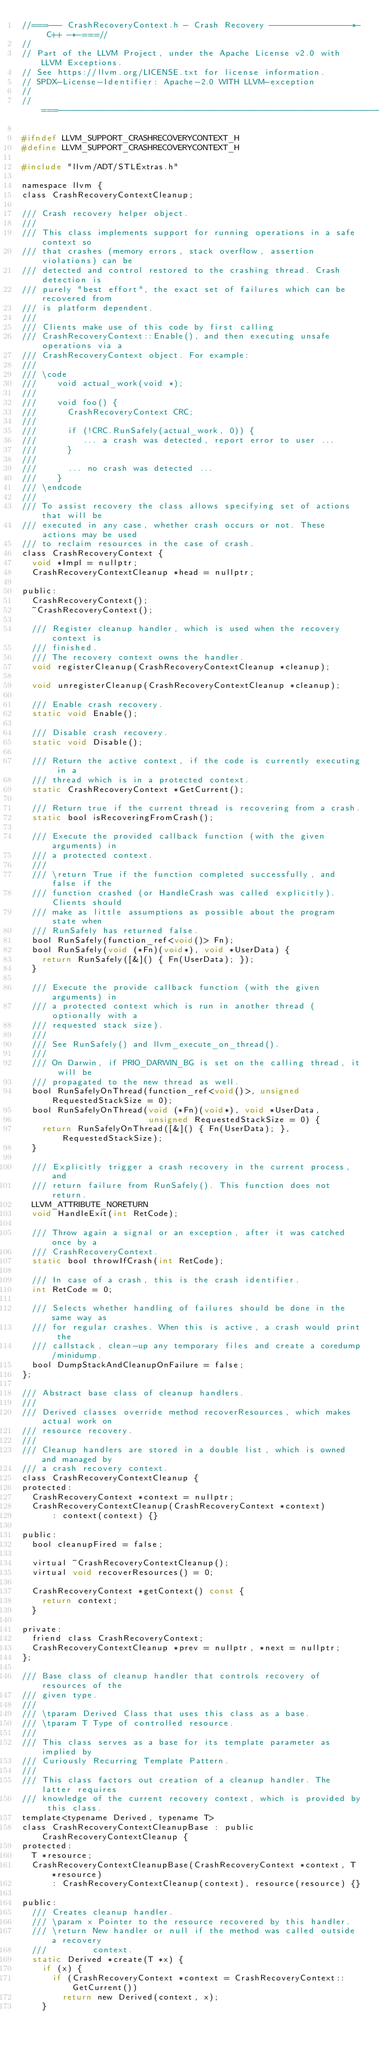<code> <loc_0><loc_0><loc_500><loc_500><_C_>//===--- CrashRecoveryContext.h - Crash Recovery ----------------*- C++ -*-===//
//
// Part of the LLVM Project, under the Apache License v2.0 with LLVM Exceptions.
// See https://llvm.org/LICENSE.txt for license information.
// SPDX-License-Identifier: Apache-2.0 WITH LLVM-exception
//
//===----------------------------------------------------------------------===//

#ifndef LLVM_SUPPORT_CRASHRECOVERYCONTEXT_H
#define LLVM_SUPPORT_CRASHRECOVERYCONTEXT_H

#include "llvm/ADT/STLExtras.h"

namespace llvm {
class CrashRecoveryContextCleanup;

/// Crash recovery helper object.
///
/// This class implements support for running operations in a safe context so
/// that crashes (memory errors, stack overflow, assertion violations) can be
/// detected and control restored to the crashing thread. Crash detection is
/// purely "best effort", the exact set of failures which can be recovered from
/// is platform dependent.
///
/// Clients make use of this code by first calling
/// CrashRecoveryContext::Enable(), and then executing unsafe operations via a
/// CrashRecoveryContext object. For example:
///
/// \code
///    void actual_work(void *);
///
///    void foo() {
///      CrashRecoveryContext CRC;
///
///      if (!CRC.RunSafely(actual_work, 0)) {
///         ... a crash was detected, report error to user ...
///      }
///
///      ... no crash was detected ...
///    }
/// \endcode
///
/// To assist recovery the class allows specifying set of actions that will be
/// executed in any case, whether crash occurs or not. These actions may be used
/// to reclaim resources in the case of crash.
class CrashRecoveryContext {
  void *Impl = nullptr;
  CrashRecoveryContextCleanup *head = nullptr;

public:
  CrashRecoveryContext();
  ~CrashRecoveryContext();

  /// Register cleanup handler, which is used when the recovery context is
  /// finished.
  /// The recovery context owns the handler.
  void registerCleanup(CrashRecoveryContextCleanup *cleanup);

  void unregisterCleanup(CrashRecoveryContextCleanup *cleanup);

  /// Enable crash recovery.
  static void Enable();

  /// Disable crash recovery.
  static void Disable();

  /// Return the active context, if the code is currently executing in a
  /// thread which is in a protected context.
  static CrashRecoveryContext *GetCurrent();

  /// Return true if the current thread is recovering from a crash.
  static bool isRecoveringFromCrash();

  /// Execute the provided callback function (with the given arguments) in
  /// a protected context.
  ///
  /// \return True if the function completed successfully, and false if the
  /// function crashed (or HandleCrash was called explicitly). Clients should
  /// make as little assumptions as possible about the program state when
  /// RunSafely has returned false.
  bool RunSafely(function_ref<void()> Fn);
  bool RunSafely(void (*Fn)(void*), void *UserData) {
    return RunSafely([&]() { Fn(UserData); });
  }

  /// Execute the provide callback function (with the given arguments) in
  /// a protected context which is run in another thread (optionally with a
  /// requested stack size).
  ///
  /// See RunSafely() and llvm_execute_on_thread().
  ///
  /// On Darwin, if PRIO_DARWIN_BG is set on the calling thread, it will be
  /// propagated to the new thread as well.
  bool RunSafelyOnThread(function_ref<void()>, unsigned RequestedStackSize = 0);
  bool RunSafelyOnThread(void (*Fn)(void*), void *UserData,
                         unsigned RequestedStackSize = 0) {
    return RunSafelyOnThread([&]() { Fn(UserData); }, RequestedStackSize);
  }

  /// Explicitly trigger a crash recovery in the current process, and
  /// return failure from RunSafely(). This function does not return.
  LLVM_ATTRIBUTE_NORETURN
  void HandleExit(int RetCode);

  /// Throw again a signal or an exception, after it was catched once by a
  /// CrashRecoveryContext.
  static bool throwIfCrash(int RetCode);

  /// In case of a crash, this is the crash identifier.
  int RetCode = 0;

  /// Selects whether handling of failures should be done in the same way as
  /// for regular crashes. When this is active, a crash would print the
  /// callstack, clean-up any temporary files and create a coredump/minidump.
  bool DumpStackAndCleanupOnFailure = false;
};

/// Abstract base class of cleanup handlers.
///
/// Derived classes override method recoverResources, which makes actual work on
/// resource recovery.
///
/// Cleanup handlers are stored in a double list, which is owned and managed by
/// a crash recovery context.
class CrashRecoveryContextCleanup {
protected:
  CrashRecoveryContext *context = nullptr;
  CrashRecoveryContextCleanup(CrashRecoveryContext *context)
      : context(context) {}

public:
  bool cleanupFired = false;

  virtual ~CrashRecoveryContextCleanup();
  virtual void recoverResources() = 0;

  CrashRecoveryContext *getContext() const {
    return context;
  }

private:
  friend class CrashRecoveryContext;
  CrashRecoveryContextCleanup *prev = nullptr, *next = nullptr;
};

/// Base class of cleanup handler that controls recovery of resources of the
/// given type.
///
/// \tparam Derived Class that uses this class as a base.
/// \tparam T Type of controlled resource.
///
/// This class serves as a base for its template parameter as implied by
/// Curiously Recurring Template Pattern.
///
/// This class factors out creation of a cleanup handler. The latter requires
/// knowledge of the current recovery context, which is provided by this class.
template<typename Derived, typename T>
class CrashRecoveryContextCleanupBase : public CrashRecoveryContextCleanup {
protected:
  T *resource;
  CrashRecoveryContextCleanupBase(CrashRecoveryContext *context, T *resource)
      : CrashRecoveryContextCleanup(context), resource(resource) {}

public:
  /// Creates cleanup handler.
  /// \param x Pointer to the resource recovered by this handler.
  /// \return New handler or null if the method was called outside a recovery
  ///         context.
  static Derived *create(T *x) {
    if (x) {
      if (CrashRecoveryContext *context = CrashRecoveryContext::GetCurrent())
        return new Derived(context, x);
    }</code> 